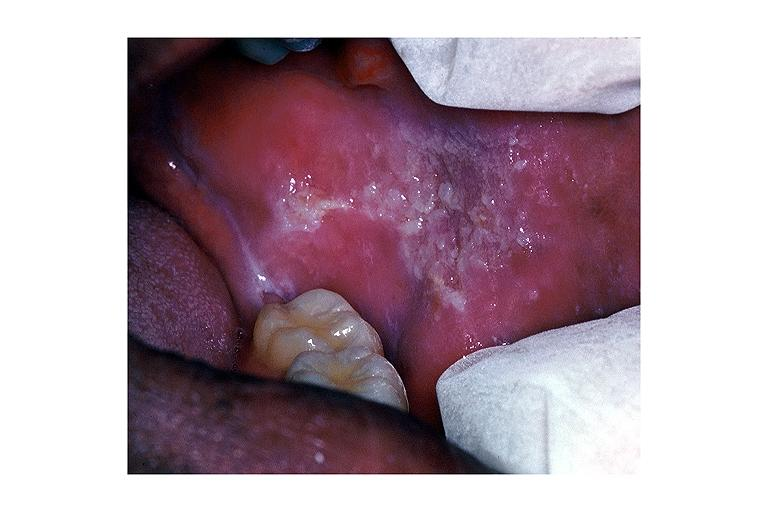what does this image show?
Answer the question using a single word or phrase. Leukoplakia 